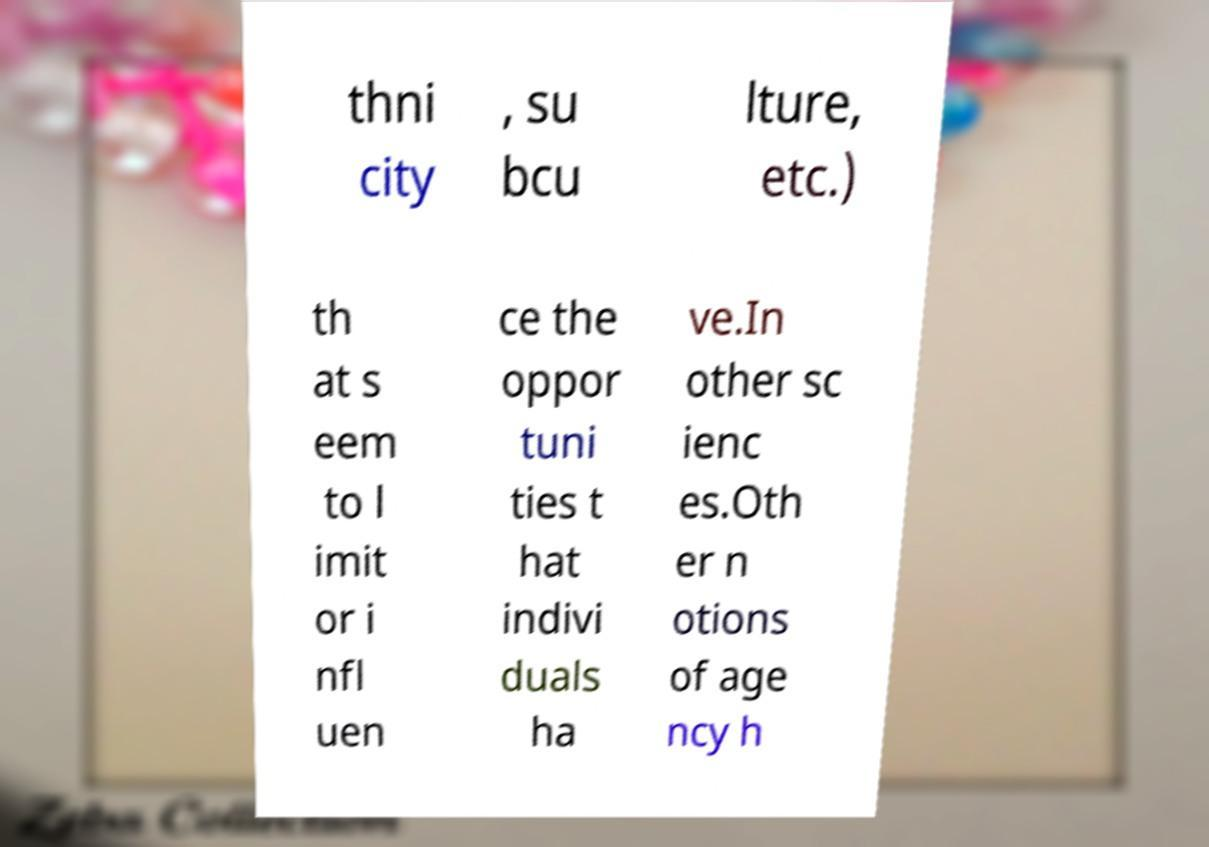Please read and relay the text visible in this image. What does it say? thni city , su bcu lture, etc.) th at s eem to l imit or i nfl uen ce the oppor tuni ties t hat indivi duals ha ve.In other sc ienc es.Oth er n otions of age ncy h 